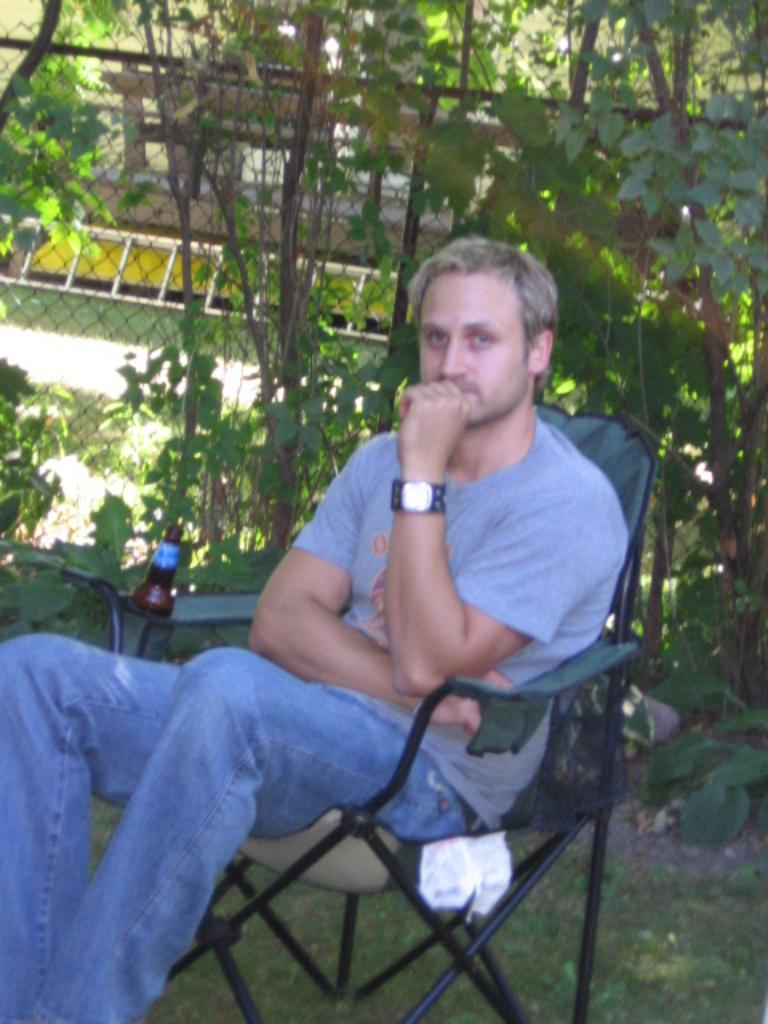Who is present in the image? There is a man in the image. What is the man doing in the image? The man is sitting on a chair in the image. Where is the chair located? The chair is located in a garden. What object is beside the man? There is a bottle beside the man. What can be seen behind the man? There is a mesh behind the man. What type of vegetation is visible in the image? There are plants visible in the image. What time of day is it in the image, considering the presence of the morning ornament? There is no mention of a morning ornament in the image, and therefore no indication of the time of day. 